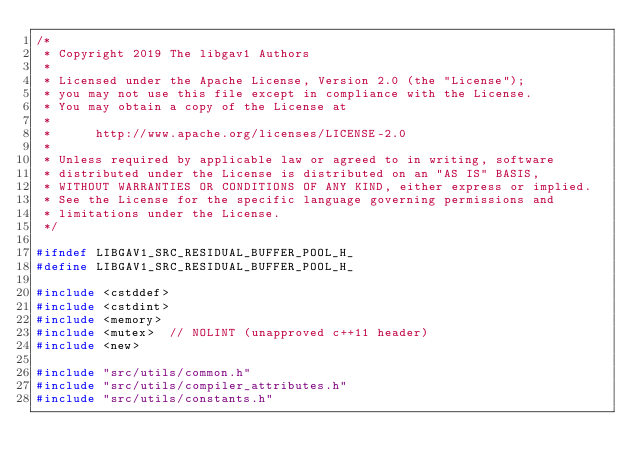<code> <loc_0><loc_0><loc_500><loc_500><_C_>/*
 * Copyright 2019 The libgav1 Authors
 *
 * Licensed under the Apache License, Version 2.0 (the "License");
 * you may not use this file except in compliance with the License.
 * You may obtain a copy of the License at
 *
 *      http://www.apache.org/licenses/LICENSE-2.0
 *
 * Unless required by applicable law or agreed to in writing, software
 * distributed under the License is distributed on an "AS IS" BASIS,
 * WITHOUT WARRANTIES OR CONDITIONS OF ANY KIND, either express or implied.
 * See the License for the specific language governing permissions and
 * limitations under the License.
 */

#ifndef LIBGAV1_SRC_RESIDUAL_BUFFER_POOL_H_
#define LIBGAV1_SRC_RESIDUAL_BUFFER_POOL_H_

#include <cstddef>
#include <cstdint>
#include <memory>
#include <mutex>  // NOLINT (unapproved c++11 header)
#include <new>

#include "src/utils/common.h"
#include "src/utils/compiler_attributes.h"
#include "src/utils/constants.h"</code> 